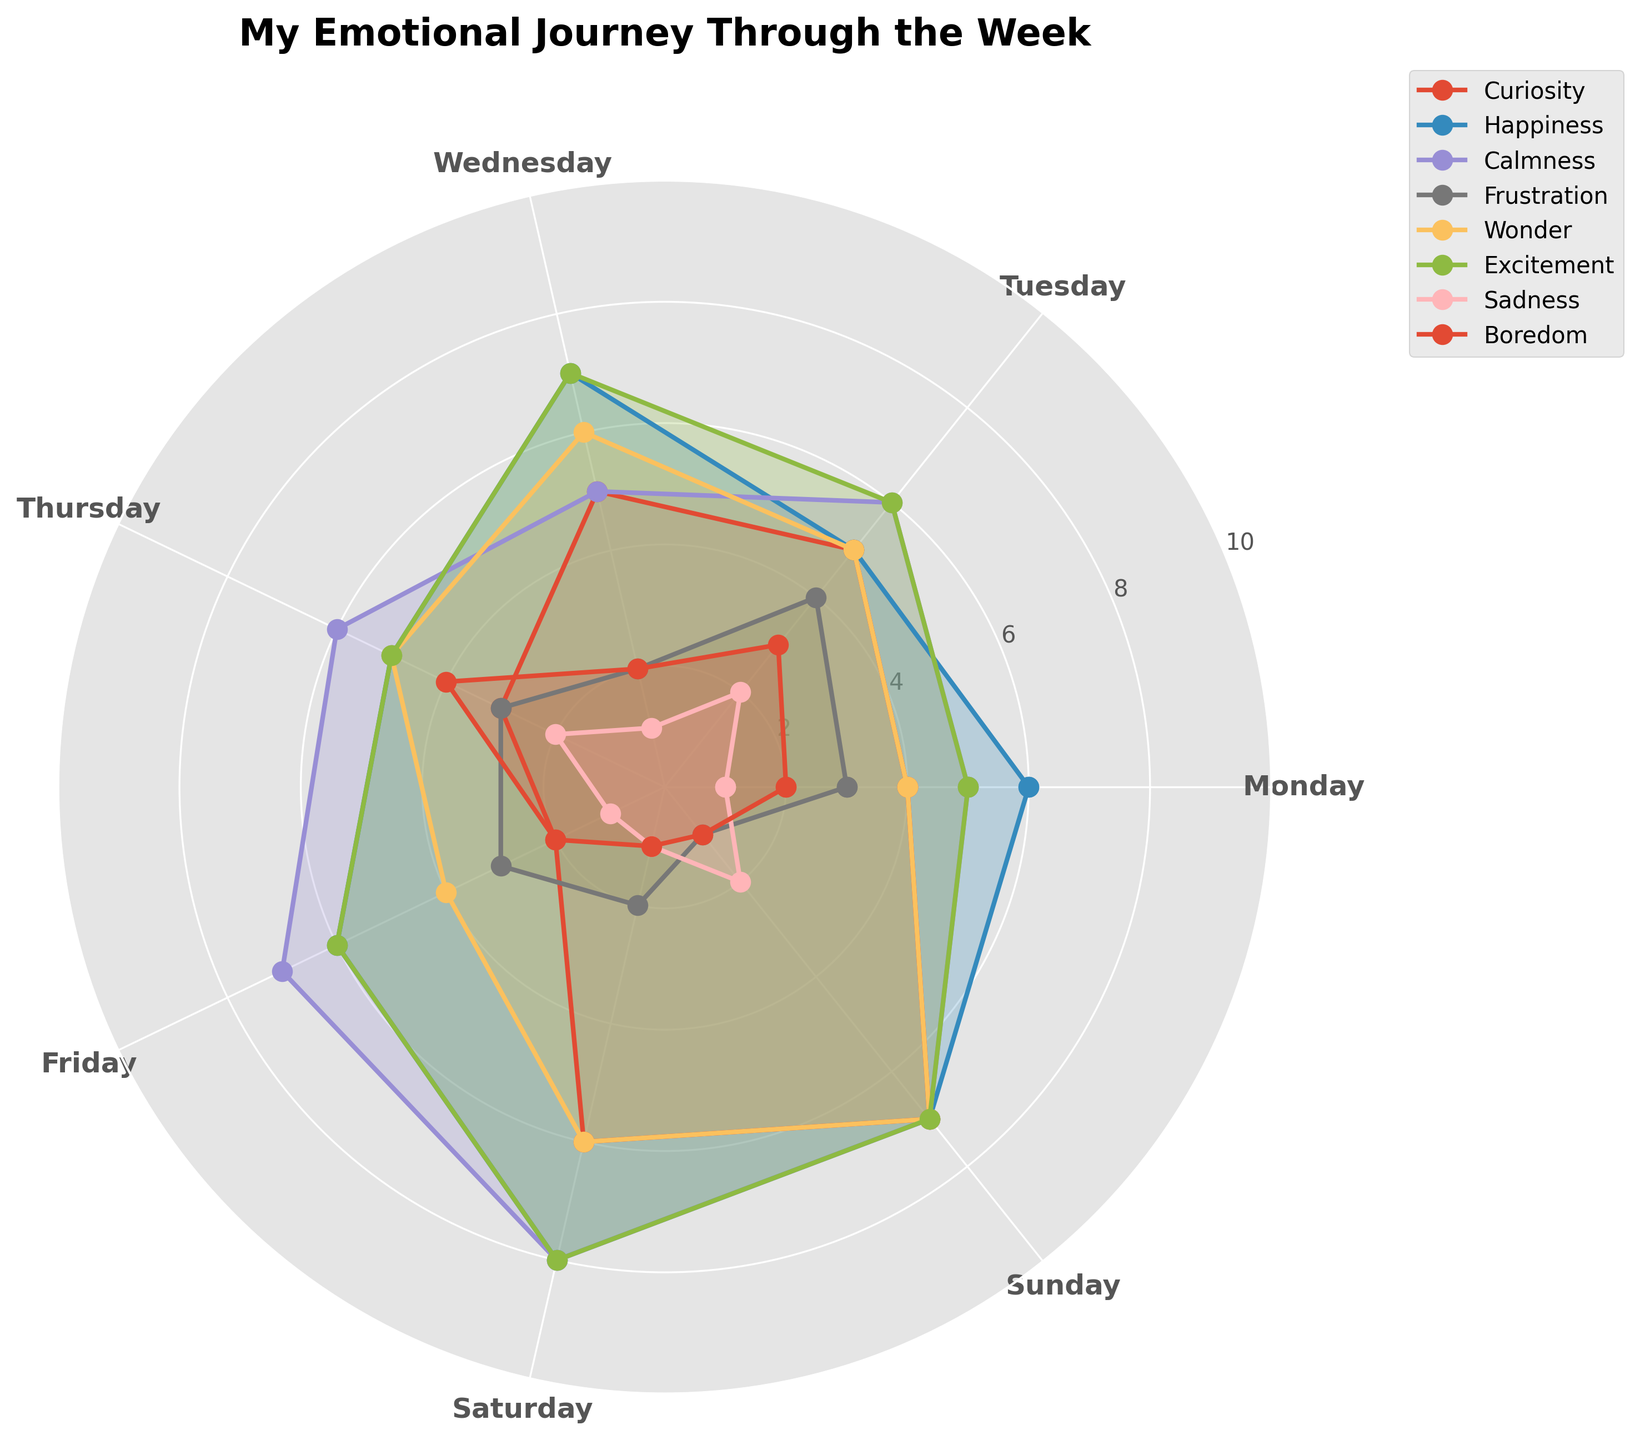What is the title of the chart? The text at the top center of the chart mentions the title clearly.
Answer: My Emotional Journey Through the Week How many different emotional states are represented in the figure? By counting the number of distinct labels or lines on the plot, we can determine the number of emotional states represented.
Answer: Eight Which day shows the highest level of happiness? By following the Happiness line (usually denoted by a label) and identifying the day on the angular direction with the highest radial value, we can find the answer.
Answer: Saturday What emotions have their highest values on Sunday? Observing each line or region on the plot extending towards Sunday, we find the highest radial values for those emotions.
Answer: Curiosity, Wonder, Excitement Which emotional state has the lowest value on Friday? By scanning the radial values around the angular direction for Friday and finding the lowest positioned line or filled area, we identify the emotion.
Answer: Sadness How did the level of calmness change from Monday to Sunday? Observing the Calmness line, track its radial values from Monday to Sunday and note whether it increases, decreases, or remains steady.
Answer: Increased Which day shows the highest average of all emotions combined? Calculate the average radial value for each day by summing up the values of all emotions per day and dividing by the number of emotions, then compare these averages.
Answer: Saturday Do Curiosity and Excitement ever have the same value on any day? By comparing the radial values for Curiosity and Excitement on each day, check if there’s any overlap in their values.
Answer: Yes, on Tuesday Which emotion shows the greatest decrease from Thursday to Friday? By calculating the differences in radial values between Thursday and Friday for each emotion, identify the largest negative change.
Answer: Wonder 